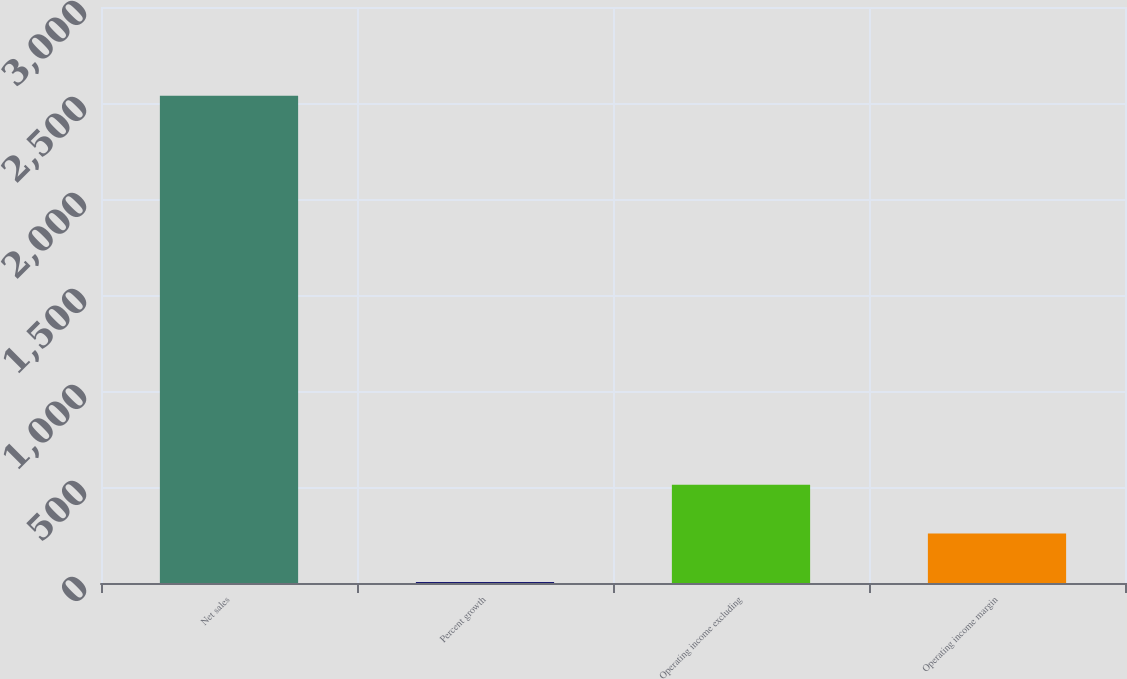<chart> <loc_0><loc_0><loc_500><loc_500><bar_chart><fcel>Net sales<fcel>Percent growth<fcel>Operating income excluding<fcel>Operating income margin<nl><fcel>2538<fcel>5.1<fcel>511.68<fcel>258.39<nl></chart> 